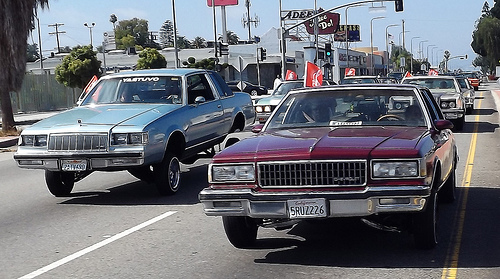<image>
Is the car in the road? Yes. The car is contained within or inside the road, showing a containment relationship. 